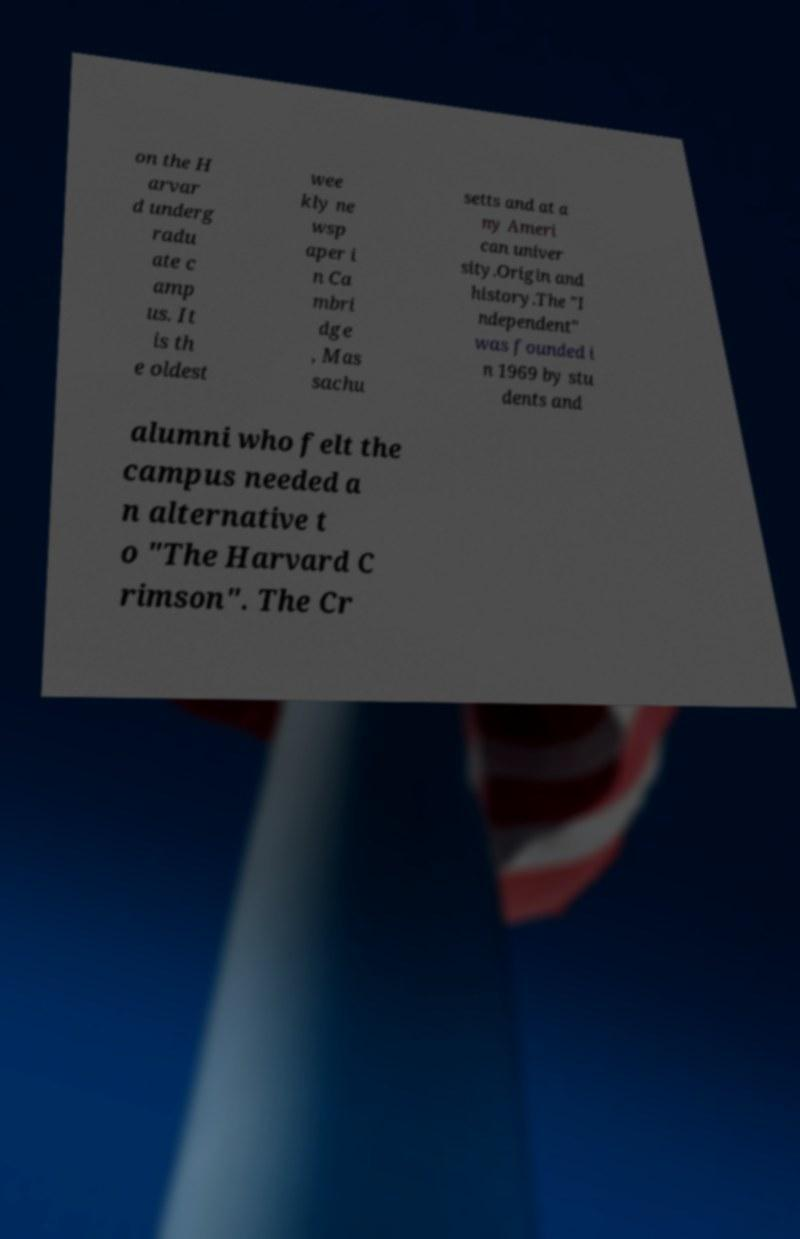For documentation purposes, I need the text within this image transcribed. Could you provide that? on the H arvar d underg radu ate c amp us. It is th e oldest wee kly ne wsp aper i n Ca mbri dge , Mas sachu setts and at a ny Ameri can univer sity.Origin and history.The "I ndependent" was founded i n 1969 by stu dents and alumni who felt the campus needed a n alternative t o "The Harvard C rimson". The Cr 